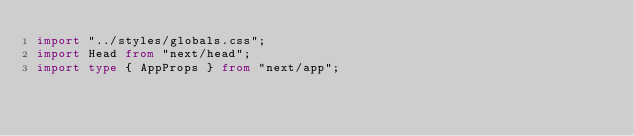<code> <loc_0><loc_0><loc_500><loc_500><_TypeScript_>import "../styles/globals.css";
import Head from "next/head";
import type { AppProps } from "next/app";</code> 